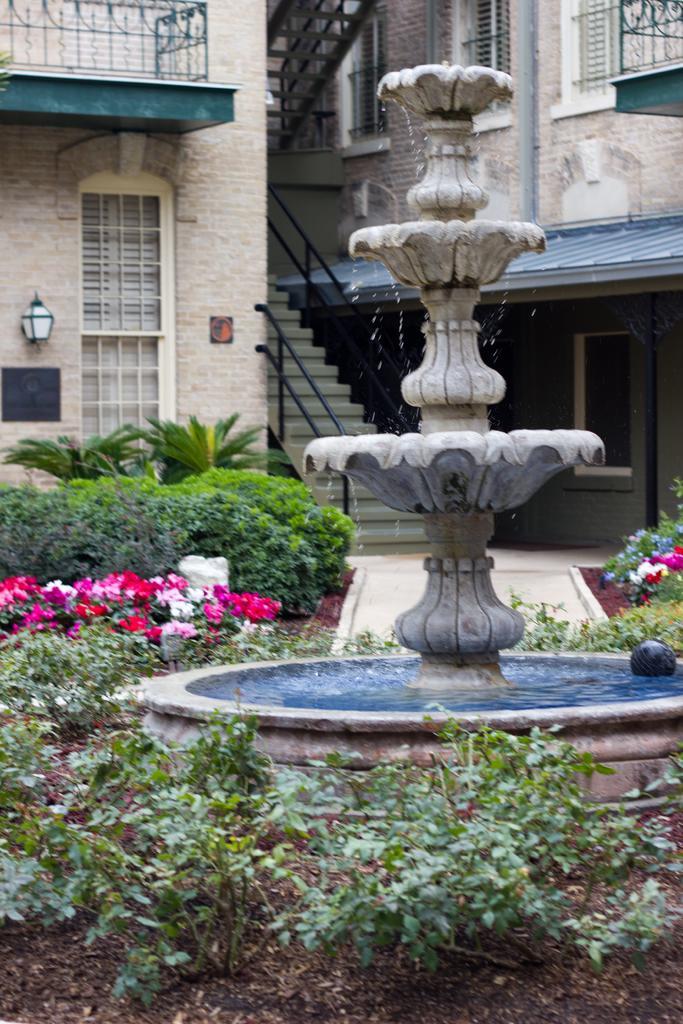How would you summarize this image in a sentence or two? In this image we can see a fountain. We can also see some plants with flowers. On the backside we can see a building with windows, lamp, stairs and a roof. 